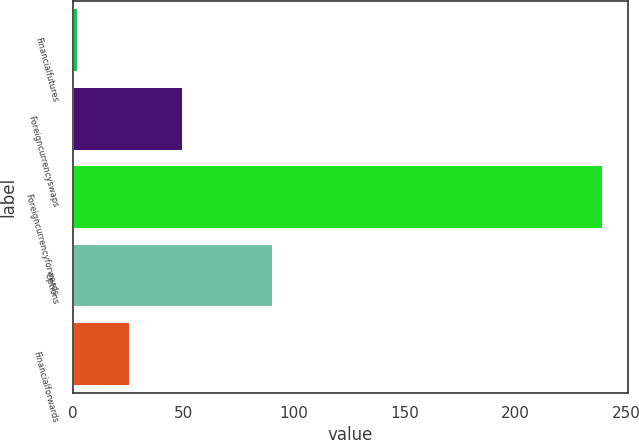<chart> <loc_0><loc_0><loc_500><loc_500><bar_chart><fcel>Financialfutures<fcel>Foreigncurrencyswaps<fcel>Foreigncurrencyforwards<fcel>Options<fcel>Financialforwards<nl><fcel>2<fcel>49.4<fcel>239<fcel>90<fcel>25.7<nl></chart> 